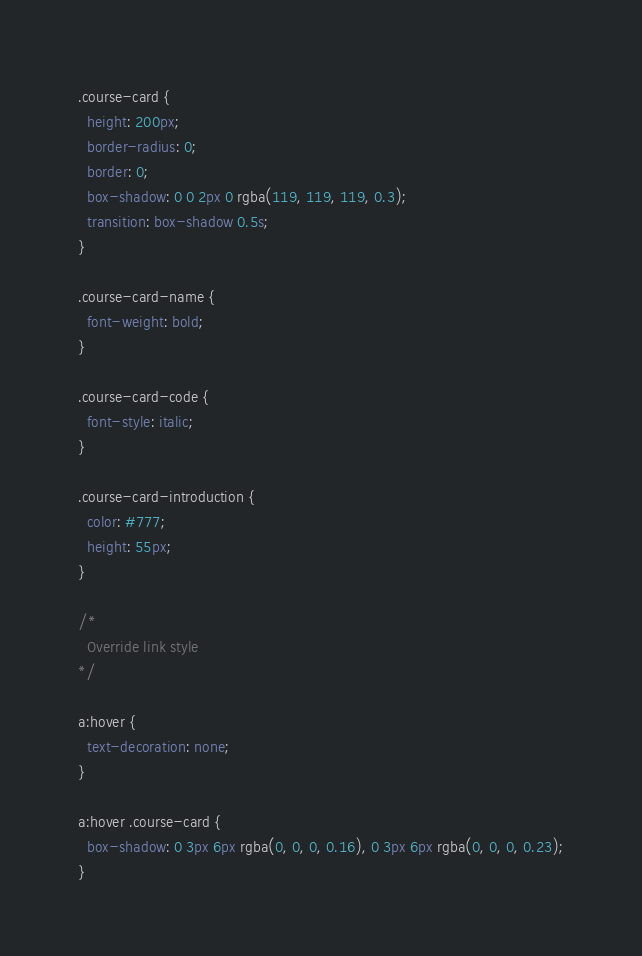Convert code to text. <code><loc_0><loc_0><loc_500><loc_500><_CSS_>.course-card {
  height: 200px;
  border-radius: 0;
  border: 0;
  box-shadow: 0 0 2px 0 rgba(119, 119, 119, 0.3);
  transition: box-shadow 0.5s;
}

.course-card-name {
  font-weight: bold;
}

.course-card-code {
  font-style: italic;
}

.course-card-introduction {
  color: #777;
  height: 55px;
}

/*
  Override link style
*/

a:hover {
  text-decoration: none;
}

a:hover .course-card {
  box-shadow: 0 3px 6px rgba(0, 0, 0, 0.16), 0 3px 6px rgba(0, 0, 0, 0.23);
}</code> 